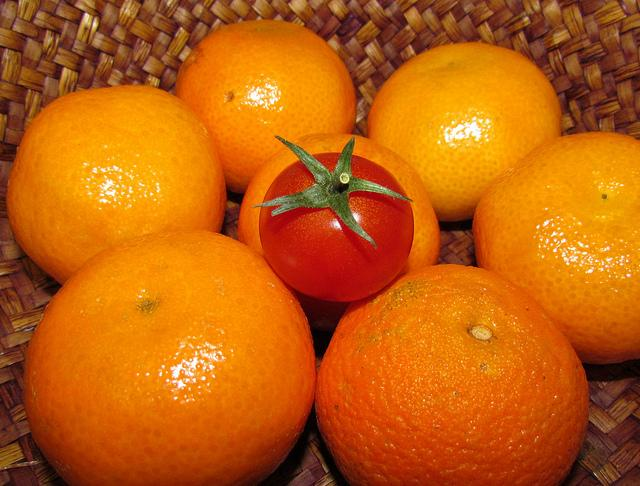What vegetable is shown in the picture? tomato 